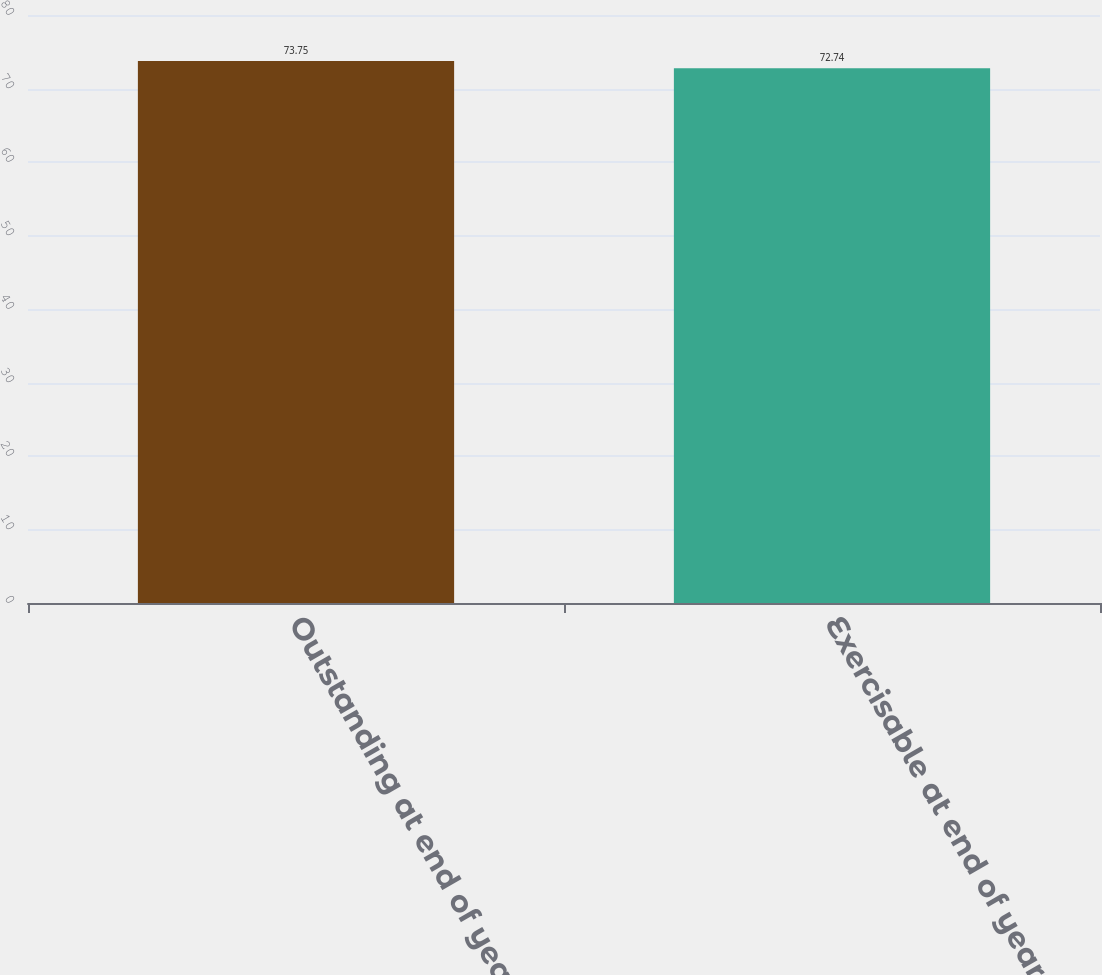<chart> <loc_0><loc_0><loc_500><loc_500><bar_chart><fcel>Outstanding at end of year<fcel>Exercisable at end of year<nl><fcel>73.75<fcel>72.74<nl></chart> 